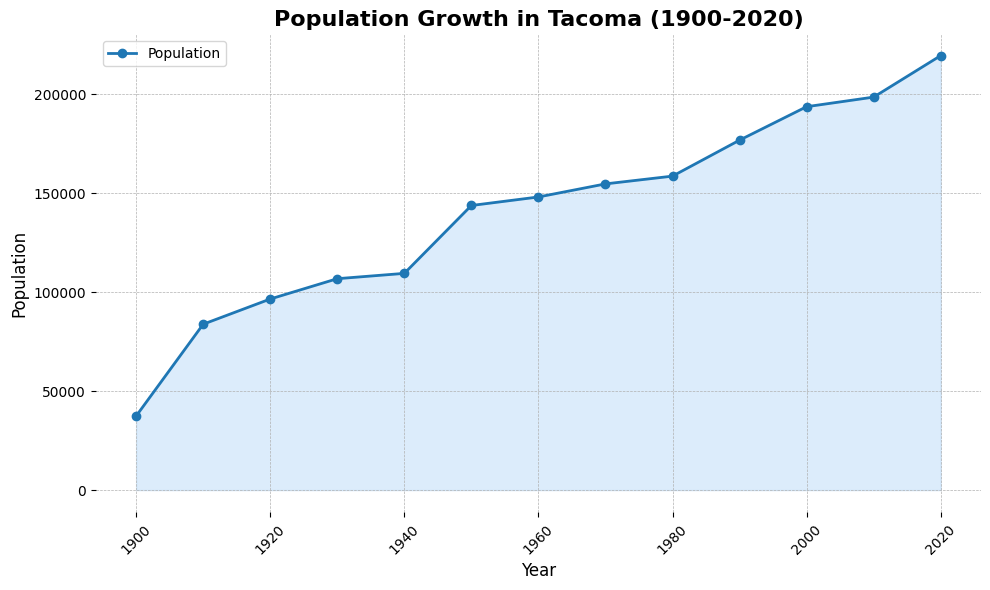What is the population of Tacoma in the year 1930? Refer to the graph and find the data point for the year 1930 on the x-axis, then look at the corresponding population value on the y-axis.
Answer: 106721 Between which two decades did Tacoma experience the largest population growth? Compare the increase in population between each consecutive decade by subtracting the earlier year’s population from the later year’s population. Determine which difference is the greatest. For example, 1950-1940: (143673 - 109408) = 34265. Continue this comparison for all pairs.
Answer: 1940 to 1950 How much did the population increase from 1900 to 2020? Subtract the population of Tacoma in 1900 from the population in 2020. That is, 219346 - 37382.
Answer: 181964 Which decade saw the smallest population growth? Calculate the population growth for each decade by subtracting the population of the earlier year from the population of the later year. Identify the decade with the smallest difference. For example, 1960-1950: (147979 - 143673) = 4306. Continue this calculation for all decades.
Answer: 1930 to 1940 What is the average population of Tacoma throughout the shown years? Add all the population values together and divide by the number of years. So, (37382 + 83743 + 96465 + 106721 + 109408 + 143673 + 147979 + 154581 + 158501 + 176664 + 193556 + 198397 + 219346) / 13.
Answer: 138681 In which year did Tacoma have a population close to 100,000? Look at the y-axis and find the point where the population is close to 100,000, then find the corresponding year on the x-axis.
Answer: 1920 By how much did the population change between 2000 and 2010? Subtract the population in the year 2010 from that in 2000. That is, 198397 - 193556.
Answer: 4841 During which period was the population growth relatively flat or minimal? Analyze the slope of the line graph. A flat or minimal slope indicates minimal growth. Identify the periods where the slope of the line is least steep. For example, between 1930 and 1940.
Answer: 1930 to 1940 or 1970 to 1980 Which two consecutive decades saw the largest change in the slope of the graph? Evaluate the changes in slope by analyzing the lines between each decade. The largest change will be where the line’s direction changes the most sharply. Observe the steepness difference between each consecutive pair of lines.
Answer: 1940 to 1950 and 1950 to 1960 